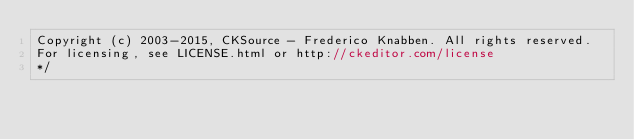<code> <loc_0><loc_0><loc_500><loc_500><_JavaScript_>Copyright (c) 2003-2015, CKSource - Frederico Knabben. All rights reserved.
For licensing, see LICENSE.html or http://ckeditor.com/license
*/
</code> 